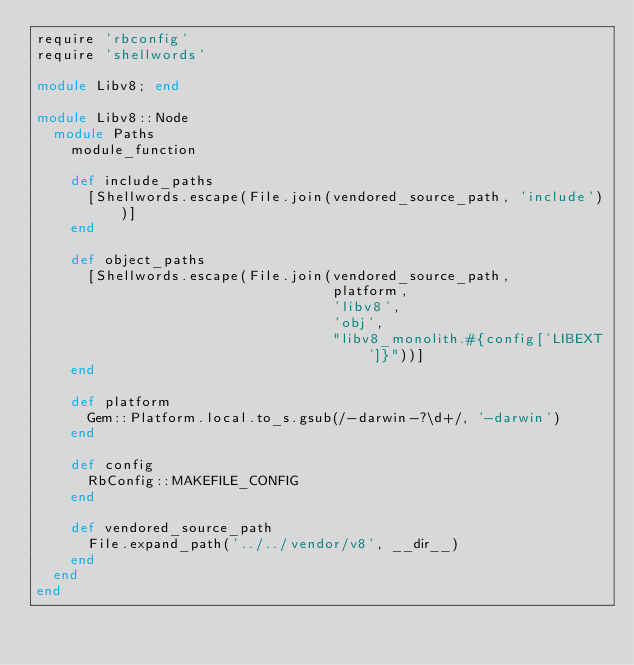Convert code to text. <code><loc_0><loc_0><loc_500><loc_500><_Ruby_>require 'rbconfig'
require 'shellwords'

module Libv8; end

module Libv8::Node
  module Paths
    module_function

    def include_paths
      [Shellwords.escape(File.join(vendored_source_path, 'include'))]
    end

    def object_paths
      [Shellwords.escape(File.join(vendored_source_path,
                                   platform,
                                   'libv8',
                                   'obj',
                                   "libv8_monolith.#{config['LIBEXT']}"))]
    end

    def platform
      Gem::Platform.local.to_s.gsub(/-darwin-?\d+/, '-darwin')
    end

    def config
      RbConfig::MAKEFILE_CONFIG
    end

    def vendored_source_path
      File.expand_path('../../vendor/v8', __dir__)
    end
  end
end
</code> 